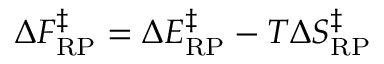<formula> <loc_0><loc_0><loc_500><loc_500>\Delta F _ { R P } ^ { \ddagger } = \Delta E _ { R P } ^ { \ddagger } - T \Delta S _ { R P } ^ { \ddagger }</formula> 